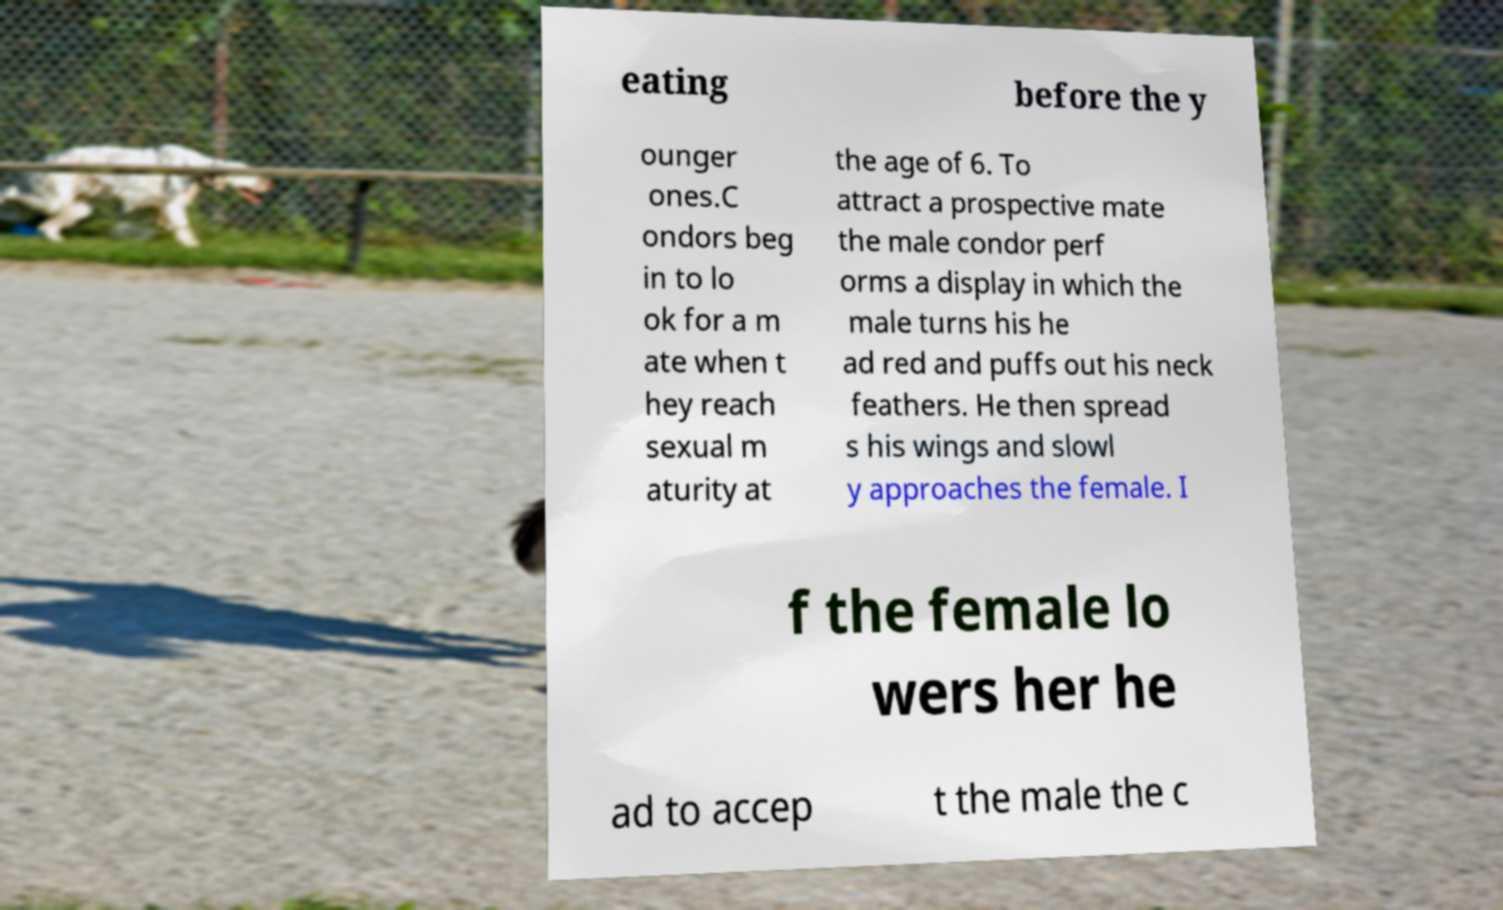I need the written content from this picture converted into text. Can you do that? eating before the y ounger ones.C ondors beg in to lo ok for a m ate when t hey reach sexual m aturity at the age of 6. To attract a prospective mate the male condor perf orms a display in which the male turns his he ad red and puffs out his neck feathers. He then spread s his wings and slowl y approaches the female. I f the female lo wers her he ad to accep t the male the c 